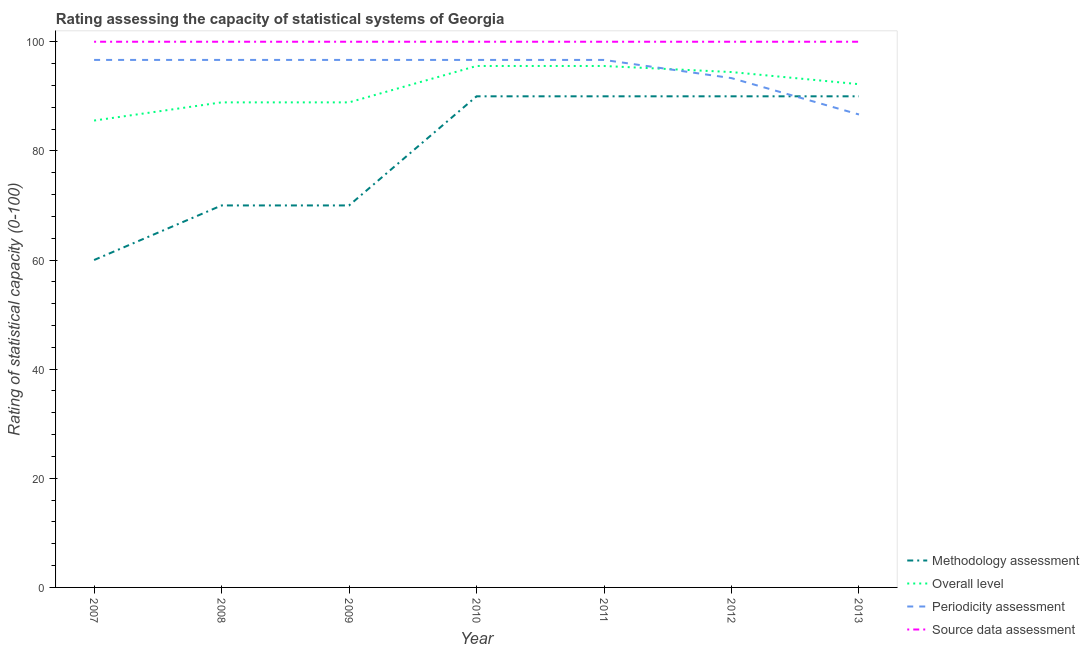How many different coloured lines are there?
Provide a succinct answer. 4. What is the overall level rating in 2008?
Ensure brevity in your answer.  88.89. Across all years, what is the maximum overall level rating?
Your answer should be compact. 95.56. Across all years, what is the minimum periodicity assessment rating?
Your response must be concise. 86.67. What is the total periodicity assessment rating in the graph?
Your answer should be very brief. 663.33. What is the difference between the overall level rating in 2010 and that in 2011?
Keep it short and to the point. 0. What is the difference between the methodology assessment rating in 2007 and the periodicity assessment rating in 2008?
Your answer should be very brief. -36.67. What is the average source data assessment rating per year?
Make the answer very short. 100. In the year 2011, what is the difference between the methodology assessment rating and overall level rating?
Your answer should be very brief. -5.56. What is the ratio of the methodology assessment rating in 2007 to that in 2010?
Provide a succinct answer. 0.67. Is the difference between the source data assessment rating in 2009 and 2011 greater than the difference between the methodology assessment rating in 2009 and 2011?
Your answer should be compact. Yes. In how many years, is the source data assessment rating greater than the average source data assessment rating taken over all years?
Your response must be concise. 0. Is the sum of the overall level rating in 2008 and 2009 greater than the maximum source data assessment rating across all years?
Make the answer very short. Yes. Is it the case that in every year, the sum of the methodology assessment rating and overall level rating is greater than the periodicity assessment rating?
Provide a short and direct response. Yes. How many lines are there?
Your response must be concise. 4. How many years are there in the graph?
Provide a short and direct response. 7. What is the difference between two consecutive major ticks on the Y-axis?
Offer a terse response. 20. Are the values on the major ticks of Y-axis written in scientific E-notation?
Your answer should be very brief. No. What is the title of the graph?
Ensure brevity in your answer.  Rating assessing the capacity of statistical systems of Georgia. Does "Primary education" appear as one of the legend labels in the graph?
Your answer should be compact. No. What is the label or title of the Y-axis?
Provide a succinct answer. Rating of statistical capacity (0-100). What is the Rating of statistical capacity (0-100) of Methodology assessment in 2007?
Your answer should be very brief. 60. What is the Rating of statistical capacity (0-100) in Overall level in 2007?
Your response must be concise. 85.56. What is the Rating of statistical capacity (0-100) in Periodicity assessment in 2007?
Offer a very short reply. 96.67. What is the Rating of statistical capacity (0-100) of Overall level in 2008?
Keep it short and to the point. 88.89. What is the Rating of statistical capacity (0-100) in Periodicity assessment in 2008?
Your response must be concise. 96.67. What is the Rating of statistical capacity (0-100) of Source data assessment in 2008?
Offer a very short reply. 100. What is the Rating of statistical capacity (0-100) of Methodology assessment in 2009?
Your answer should be very brief. 70. What is the Rating of statistical capacity (0-100) of Overall level in 2009?
Ensure brevity in your answer.  88.89. What is the Rating of statistical capacity (0-100) in Periodicity assessment in 2009?
Ensure brevity in your answer.  96.67. What is the Rating of statistical capacity (0-100) in Overall level in 2010?
Your answer should be compact. 95.56. What is the Rating of statistical capacity (0-100) of Periodicity assessment in 2010?
Your response must be concise. 96.67. What is the Rating of statistical capacity (0-100) in Source data assessment in 2010?
Provide a short and direct response. 100. What is the Rating of statistical capacity (0-100) in Methodology assessment in 2011?
Your answer should be compact. 90. What is the Rating of statistical capacity (0-100) of Overall level in 2011?
Provide a short and direct response. 95.56. What is the Rating of statistical capacity (0-100) of Periodicity assessment in 2011?
Keep it short and to the point. 96.67. What is the Rating of statistical capacity (0-100) of Source data assessment in 2011?
Offer a very short reply. 100. What is the Rating of statistical capacity (0-100) of Methodology assessment in 2012?
Make the answer very short. 90. What is the Rating of statistical capacity (0-100) in Overall level in 2012?
Provide a succinct answer. 94.44. What is the Rating of statistical capacity (0-100) of Periodicity assessment in 2012?
Your answer should be compact. 93.33. What is the Rating of statistical capacity (0-100) of Source data assessment in 2012?
Ensure brevity in your answer.  100. What is the Rating of statistical capacity (0-100) of Methodology assessment in 2013?
Your answer should be very brief. 90. What is the Rating of statistical capacity (0-100) of Overall level in 2013?
Offer a very short reply. 92.22. What is the Rating of statistical capacity (0-100) in Periodicity assessment in 2013?
Your response must be concise. 86.67. Across all years, what is the maximum Rating of statistical capacity (0-100) of Methodology assessment?
Offer a terse response. 90. Across all years, what is the maximum Rating of statistical capacity (0-100) in Overall level?
Your response must be concise. 95.56. Across all years, what is the maximum Rating of statistical capacity (0-100) of Periodicity assessment?
Offer a very short reply. 96.67. Across all years, what is the maximum Rating of statistical capacity (0-100) in Source data assessment?
Make the answer very short. 100. Across all years, what is the minimum Rating of statistical capacity (0-100) in Overall level?
Your response must be concise. 85.56. Across all years, what is the minimum Rating of statistical capacity (0-100) of Periodicity assessment?
Offer a very short reply. 86.67. Across all years, what is the minimum Rating of statistical capacity (0-100) in Source data assessment?
Offer a very short reply. 100. What is the total Rating of statistical capacity (0-100) in Methodology assessment in the graph?
Your response must be concise. 560. What is the total Rating of statistical capacity (0-100) of Overall level in the graph?
Make the answer very short. 641.11. What is the total Rating of statistical capacity (0-100) of Periodicity assessment in the graph?
Your answer should be very brief. 663.33. What is the total Rating of statistical capacity (0-100) of Source data assessment in the graph?
Your response must be concise. 700. What is the difference between the Rating of statistical capacity (0-100) of Methodology assessment in 2007 and that in 2008?
Provide a short and direct response. -10. What is the difference between the Rating of statistical capacity (0-100) in Overall level in 2007 and that in 2008?
Ensure brevity in your answer.  -3.33. What is the difference between the Rating of statistical capacity (0-100) in Periodicity assessment in 2007 and that in 2008?
Provide a short and direct response. 0. What is the difference between the Rating of statistical capacity (0-100) in Periodicity assessment in 2007 and that in 2009?
Keep it short and to the point. 0. What is the difference between the Rating of statistical capacity (0-100) of Methodology assessment in 2007 and that in 2010?
Provide a short and direct response. -30. What is the difference between the Rating of statistical capacity (0-100) in Overall level in 2007 and that in 2010?
Your answer should be very brief. -10. What is the difference between the Rating of statistical capacity (0-100) of Periodicity assessment in 2007 and that in 2010?
Offer a very short reply. 0. What is the difference between the Rating of statistical capacity (0-100) of Methodology assessment in 2007 and that in 2011?
Offer a very short reply. -30. What is the difference between the Rating of statistical capacity (0-100) of Periodicity assessment in 2007 and that in 2011?
Offer a terse response. 0. What is the difference between the Rating of statistical capacity (0-100) in Overall level in 2007 and that in 2012?
Keep it short and to the point. -8.89. What is the difference between the Rating of statistical capacity (0-100) in Overall level in 2007 and that in 2013?
Make the answer very short. -6.67. What is the difference between the Rating of statistical capacity (0-100) in Overall level in 2008 and that in 2009?
Provide a succinct answer. 0. What is the difference between the Rating of statistical capacity (0-100) in Source data assessment in 2008 and that in 2009?
Give a very brief answer. 0. What is the difference between the Rating of statistical capacity (0-100) in Methodology assessment in 2008 and that in 2010?
Your response must be concise. -20. What is the difference between the Rating of statistical capacity (0-100) of Overall level in 2008 and that in 2010?
Make the answer very short. -6.67. What is the difference between the Rating of statistical capacity (0-100) in Methodology assessment in 2008 and that in 2011?
Ensure brevity in your answer.  -20. What is the difference between the Rating of statistical capacity (0-100) in Overall level in 2008 and that in 2011?
Provide a short and direct response. -6.67. What is the difference between the Rating of statistical capacity (0-100) of Periodicity assessment in 2008 and that in 2011?
Give a very brief answer. 0. What is the difference between the Rating of statistical capacity (0-100) of Source data assessment in 2008 and that in 2011?
Make the answer very short. 0. What is the difference between the Rating of statistical capacity (0-100) in Methodology assessment in 2008 and that in 2012?
Offer a very short reply. -20. What is the difference between the Rating of statistical capacity (0-100) in Overall level in 2008 and that in 2012?
Your response must be concise. -5.56. What is the difference between the Rating of statistical capacity (0-100) in Periodicity assessment in 2008 and that in 2012?
Make the answer very short. 3.33. What is the difference between the Rating of statistical capacity (0-100) in Methodology assessment in 2008 and that in 2013?
Your response must be concise. -20. What is the difference between the Rating of statistical capacity (0-100) of Overall level in 2008 and that in 2013?
Provide a short and direct response. -3.33. What is the difference between the Rating of statistical capacity (0-100) of Periodicity assessment in 2008 and that in 2013?
Provide a short and direct response. 10. What is the difference between the Rating of statistical capacity (0-100) in Source data assessment in 2008 and that in 2013?
Provide a short and direct response. 0. What is the difference between the Rating of statistical capacity (0-100) of Methodology assessment in 2009 and that in 2010?
Ensure brevity in your answer.  -20. What is the difference between the Rating of statistical capacity (0-100) of Overall level in 2009 and that in 2010?
Your response must be concise. -6.67. What is the difference between the Rating of statistical capacity (0-100) in Periodicity assessment in 2009 and that in 2010?
Your answer should be very brief. 0. What is the difference between the Rating of statistical capacity (0-100) in Source data assessment in 2009 and that in 2010?
Offer a very short reply. 0. What is the difference between the Rating of statistical capacity (0-100) of Methodology assessment in 2009 and that in 2011?
Your answer should be very brief. -20. What is the difference between the Rating of statistical capacity (0-100) in Overall level in 2009 and that in 2011?
Your answer should be compact. -6.67. What is the difference between the Rating of statistical capacity (0-100) in Overall level in 2009 and that in 2012?
Your answer should be very brief. -5.56. What is the difference between the Rating of statistical capacity (0-100) in Periodicity assessment in 2009 and that in 2012?
Your answer should be compact. 3.33. What is the difference between the Rating of statistical capacity (0-100) in Source data assessment in 2009 and that in 2012?
Make the answer very short. 0. What is the difference between the Rating of statistical capacity (0-100) of Overall level in 2009 and that in 2013?
Offer a terse response. -3.33. What is the difference between the Rating of statistical capacity (0-100) in Source data assessment in 2009 and that in 2013?
Keep it short and to the point. 0. What is the difference between the Rating of statistical capacity (0-100) in Methodology assessment in 2010 and that in 2011?
Give a very brief answer. 0. What is the difference between the Rating of statistical capacity (0-100) of Overall level in 2010 and that in 2011?
Ensure brevity in your answer.  0. What is the difference between the Rating of statistical capacity (0-100) in Periodicity assessment in 2010 and that in 2011?
Offer a very short reply. 0. What is the difference between the Rating of statistical capacity (0-100) of Source data assessment in 2010 and that in 2011?
Provide a short and direct response. 0. What is the difference between the Rating of statistical capacity (0-100) of Methodology assessment in 2010 and that in 2012?
Give a very brief answer. 0. What is the difference between the Rating of statistical capacity (0-100) in Methodology assessment in 2010 and that in 2013?
Your answer should be very brief. 0. What is the difference between the Rating of statistical capacity (0-100) in Overall level in 2010 and that in 2013?
Your answer should be compact. 3.33. What is the difference between the Rating of statistical capacity (0-100) in Methodology assessment in 2011 and that in 2012?
Make the answer very short. 0. What is the difference between the Rating of statistical capacity (0-100) of Periodicity assessment in 2011 and that in 2012?
Give a very brief answer. 3.33. What is the difference between the Rating of statistical capacity (0-100) of Source data assessment in 2011 and that in 2012?
Your response must be concise. 0. What is the difference between the Rating of statistical capacity (0-100) in Overall level in 2011 and that in 2013?
Give a very brief answer. 3.33. What is the difference between the Rating of statistical capacity (0-100) in Overall level in 2012 and that in 2013?
Offer a terse response. 2.22. What is the difference between the Rating of statistical capacity (0-100) of Periodicity assessment in 2012 and that in 2013?
Your answer should be very brief. 6.67. What is the difference between the Rating of statistical capacity (0-100) in Source data assessment in 2012 and that in 2013?
Provide a succinct answer. 0. What is the difference between the Rating of statistical capacity (0-100) in Methodology assessment in 2007 and the Rating of statistical capacity (0-100) in Overall level in 2008?
Your answer should be very brief. -28.89. What is the difference between the Rating of statistical capacity (0-100) in Methodology assessment in 2007 and the Rating of statistical capacity (0-100) in Periodicity assessment in 2008?
Your response must be concise. -36.67. What is the difference between the Rating of statistical capacity (0-100) of Methodology assessment in 2007 and the Rating of statistical capacity (0-100) of Source data assessment in 2008?
Keep it short and to the point. -40. What is the difference between the Rating of statistical capacity (0-100) in Overall level in 2007 and the Rating of statistical capacity (0-100) in Periodicity assessment in 2008?
Provide a succinct answer. -11.11. What is the difference between the Rating of statistical capacity (0-100) of Overall level in 2007 and the Rating of statistical capacity (0-100) of Source data assessment in 2008?
Make the answer very short. -14.44. What is the difference between the Rating of statistical capacity (0-100) of Methodology assessment in 2007 and the Rating of statistical capacity (0-100) of Overall level in 2009?
Give a very brief answer. -28.89. What is the difference between the Rating of statistical capacity (0-100) in Methodology assessment in 2007 and the Rating of statistical capacity (0-100) in Periodicity assessment in 2009?
Ensure brevity in your answer.  -36.67. What is the difference between the Rating of statistical capacity (0-100) of Methodology assessment in 2007 and the Rating of statistical capacity (0-100) of Source data assessment in 2009?
Give a very brief answer. -40. What is the difference between the Rating of statistical capacity (0-100) in Overall level in 2007 and the Rating of statistical capacity (0-100) in Periodicity assessment in 2009?
Keep it short and to the point. -11.11. What is the difference between the Rating of statistical capacity (0-100) in Overall level in 2007 and the Rating of statistical capacity (0-100) in Source data assessment in 2009?
Offer a terse response. -14.44. What is the difference between the Rating of statistical capacity (0-100) of Periodicity assessment in 2007 and the Rating of statistical capacity (0-100) of Source data assessment in 2009?
Offer a terse response. -3.33. What is the difference between the Rating of statistical capacity (0-100) in Methodology assessment in 2007 and the Rating of statistical capacity (0-100) in Overall level in 2010?
Offer a very short reply. -35.56. What is the difference between the Rating of statistical capacity (0-100) of Methodology assessment in 2007 and the Rating of statistical capacity (0-100) of Periodicity assessment in 2010?
Ensure brevity in your answer.  -36.67. What is the difference between the Rating of statistical capacity (0-100) in Overall level in 2007 and the Rating of statistical capacity (0-100) in Periodicity assessment in 2010?
Provide a succinct answer. -11.11. What is the difference between the Rating of statistical capacity (0-100) in Overall level in 2007 and the Rating of statistical capacity (0-100) in Source data assessment in 2010?
Provide a short and direct response. -14.44. What is the difference between the Rating of statistical capacity (0-100) in Methodology assessment in 2007 and the Rating of statistical capacity (0-100) in Overall level in 2011?
Provide a succinct answer. -35.56. What is the difference between the Rating of statistical capacity (0-100) in Methodology assessment in 2007 and the Rating of statistical capacity (0-100) in Periodicity assessment in 2011?
Keep it short and to the point. -36.67. What is the difference between the Rating of statistical capacity (0-100) of Overall level in 2007 and the Rating of statistical capacity (0-100) of Periodicity assessment in 2011?
Offer a terse response. -11.11. What is the difference between the Rating of statistical capacity (0-100) of Overall level in 2007 and the Rating of statistical capacity (0-100) of Source data assessment in 2011?
Offer a very short reply. -14.44. What is the difference between the Rating of statistical capacity (0-100) of Periodicity assessment in 2007 and the Rating of statistical capacity (0-100) of Source data assessment in 2011?
Provide a succinct answer. -3.33. What is the difference between the Rating of statistical capacity (0-100) in Methodology assessment in 2007 and the Rating of statistical capacity (0-100) in Overall level in 2012?
Offer a very short reply. -34.44. What is the difference between the Rating of statistical capacity (0-100) in Methodology assessment in 2007 and the Rating of statistical capacity (0-100) in Periodicity assessment in 2012?
Keep it short and to the point. -33.33. What is the difference between the Rating of statistical capacity (0-100) in Methodology assessment in 2007 and the Rating of statistical capacity (0-100) in Source data assessment in 2012?
Provide a succinct answer. -40. What is the difference between the Rating of statistical capacity (0-100) in Overall level in 2007 and the Rating of statistical capacity (0-100) in Periodicity assessment in 2012?
Give a very brief answer. -7.78. What is the difference between the Rating of statistical capacity (0-100) in Overall level in 2007 and the Rating of statistical capacity (0-100) in Source data assessment in 2012?
Your answer should be compact. -14.44. What is the difference between the Rating of statistical capacity (0-100) of Periodicity assessment in 2007 and the Rating of statistical capacity (0-100) of Source data assessment in 2012?
Give a very brief answer. -3.33. What is the difference between the Rating of statistical capacity (0-100) in Methodology assessment in 2007 and the Rating of statistical capacity (0-100) in Overall level in 2013?
Make the answer very short. -32.22. What is the difference between the Rating of statistical capacity (0-100) in Methodology assessment in 2007 and the Rating of statistical capacity (0-100) in Periodicity assessment in 2013?
Offer a terse response. -26.67. What is the difference between the Rating of statistical capacity (0-100) in Methodology assessment in 2007 and the Rating of statistical capacity (0-100) in Source data assessment in 2013?
Your response must be concise. -40. What is the difference between the Rating of statistical capacity (0-100) in Overall level in 2007 and the Rating of statistical capacity (0-100) in Periodicity assessment in 2013?
Ensure brevity in your answer.  -1.11. What is the difference between the Rating of statistical capacity (0-100) of Overall level in 2007 and the Rating of statistical capacity (0-100) of Source data assessment in 2013?
Ensure brevity in your answer.  -14.44. What is the difference between the Rating of statistical capacity (0-100) of Methodology assessment in 2008 and the Rating of statistical capacity (0-100) of Overall level in 2009?
Provide a short and direct response. -18.89. What is the difference between the Rating of statistical capacity (0-100) of Methodology assessment in 2008 and the Rating of statistical capacity (0-100) of Periodicity assessment in 2009?
Provide a short and direct response. -26.67. What is the difference between the Rating of statistical capacity (0-100) in Methodology assessment in 2008 and the Rating of statistical capacity (0-100) in Source data assessment in 2009?
Offer a terse response. -30. What is the difference between the Rating of statistical capacity (0-100) of Overall level in 2008 and the Rating of statistical capacity (0-100) of Periodicity assessment in 2009?
Provide a short and direct response. -7.78. What is the difference between the Rating of statistical capacity (0-100) in Overall level in 2008 and the Rating of statistical capacity (0-100) in Source data assessment in 2009?
Offer a terse response. -11.11. What is the difference between the Rating of statistical capacity (0-100) of Periodicity assessment in 2008 and the Rating of statistical capacity (0-100) of Source data assessment in 2009?
Offer a very short reply. -3.33. What is the difference between the Rating of statistical capacity (0-100) in Methodology assessment in 2008 and the Rating of statistical capacity (0-100) in Overall level in 2010?
Your answer should be very brief. -25.56. What is the difference between the Rating of statistical capacity (0-100) of Methodology assessment in 2008 and the Rating of statistical capacity (0-100) of Periodicity assessment in 2010?
Your answer should be compact. -26.67. What is the difference between the Rating of statistical capacity (0-100) of Methodology assessment in 2008 and the Rating of statistical capacity (0-100) of Source data assessment in 2010?
Your answer should be compact. -30. What is the difference between the Rating of statistical capacity (0-100) in Overall level in 2008 and the Rating of statistical capacity (0-100) in Periodicity assessment in 2010?
Your answer should be very brief. -7.78. What is the difference between the Rating of statistical capacity (0-100) in Overall level in 2008 and the Rating of statistical capacity (0-100) in Source data assessment in 2010?
Provide a succinct answer. -11.11. What is the difference between the Rating of statistical capacity (0-100) of Periodicity assessment in 2008 and the Rating of statistical capacity (0-100) of Source data assessment in 2010?
Make the answer very short. -3.33. What is the difference between the Rating of statistical capacity (0-100) in Methodology assessment in 2008 and the Rating of statistical capacity (0-100) in Overall level in 2011?
Offer a very short reply. -25.56. What is the difference between the Rating of statistical capacity (0-100) in Methodology assessment in 2008 and the Rating of statistical capacity (0-100) in Periodicity assessment in 2011?
Your answer should be compact. -26.67. What is the difference between the Rating of statistical capacity (0-100) of Methodology assessment in 2008 and the Rating of statistical capacity (0-100) of Source data assessment in 2011?
Give a very brief answer. -30. What is the difference between the Rating of statistical capacity (0-100) in Overall level in 2008 and the Rating of statistical capacity (0-100) in Periodicity assessment in 2011?
Your answer should be very brief. -7.78. What is the difference between the Rating of statistical capacity (0-100) of Overall level in 2008 and the Rating of statistical capacity (0-100) of Source data assessment in 2011?
Your answer should be very brief. -11.11. What is the difference between the Rating of statistical capacity (0-100) in Methodology assessment in 2008 and the Rating of statistical capacity (0-100) in Overall level in 2012?
Give a very brief answer. -24.44. What is the difference between the Rating of statistical capacity (0-100) of Methodology assessment in 2008 and the Rating of statistical capacity (0-100) of Periodicity assessment in 2012?
Keep it short and to the point. -23.33. What is the difference between the Rating of statistical capacity (0-100) in Methodology assessment in 2008 and the Rating of statistical capacity (0-100) in Source data assessment in 2012?
Your response must be concise. -30. What is the difference between the Rating of statistical capacity (0-100) of Overall level in 2008 and the Rating of statistical capacity (0-100) of Periodicity assessment in 2012?
Provide a succinct answer. -4.44. What is the difference between the Rating of statistical capacity (0-100) of Overall level in 2008 and the Rating of statistical capacity (0-100) of Source data assessment in 2012?
Offer a terse response. -11.11. What is the difference between the Rating of statistical capacity (0-100) in Periodicity assessment in 2008 and the Rating of statistical capacity (0-100) in Source data assessment in 2012?
Offer a terse response. -3.33. What is the difference between the Rating of statistical capacity (0-100) in Methodology assessment in 2008 and the Rating of statistical capacity (0-100) in Overall level in 2013?
Your response must be concise. -22.22. What is the difference between the Rating of statistical capacity (0-100) in Methodology assessment in 2008 and the Rating of statistical capacity (0-100) in Periodicity assessment in 2013?
Provide a short and direct response. -16.67. What is the difference between the Rating of statistical capacity (0-100) of Methodology assessment in 2008 and the Rating of statistical capacity (0-100) of Source data assessment in 2013?
Give a very brief answer. -30. What is the difference between the Rating of statistical capacity (0-100) of Overall level in 2008 and the Rating of statistical capacity (0-100) of Periodicity assessment in 2013?
Provide a succinct answer. 2.22. What is the difference between the Rating of statistical capacity (0-100) of Overall level in 2008 and the Rating of statistical capacity (0-100) of Source data assessment in 2013?
Offer a terse response. -11.11. What is the difference between the Rating of statistical capacity (0-100) in Periodicity assessment in 2008 and the Rating of statistical capacity (0-100) in Source data assessment in 2013?
Your answer should be compact. -3.33. What is the difference between the Rating of statistical capacity (0-100) of Methodology assessment in 2009 and the Rating of statistical capacity (0-100) of Overall level in 2010?
Give a very brief answer. -25.56. What is the difference between the Rating of statistical capacity (0-100) in Methodology assessment in 2009 and the Rating of statistical capacity (0-100) in Periodicity assessment in 2010?
Provide a succinct answer. -26.67. What is the difference between the Rating of statistical capacity (0-100) of Methodology assessment in 2009 and the Rating of statistical capacity (0-100) of Source data assessment in 2010?
Your answer should be very brief. -30. What is the difference between the Rating of statistical capacity (0-100) in Overall level in 2009 and the Rating of statistical capacity (0-100) in Periodicity assessment in 2010?
Provide a succinct answer. -7.78. What is the difference between the Rating of statistical capacity (0-100) of Overall level in 2009 and the Rating of statistical capacity (0-100) of Source data assessment in 2010?
Provide a short and direct response. -11.11. What is the difference between the Rating of statistical capacity (0-100) of Methodology assessment in 2009 and the Rating of statistical capacity (0-100) of Overall level in 2011?
Offer a very short reply. -25.56. What is the difference between the Rating of statistical capacity (0-100) in Methodology assessment in 2009 and the Rating of statistical capacity (0-100) in Periodicity assessment in 2011?
Ensure brevity in your answer.  -26.67. What is the difference between the Rating of statistical capacity (0-100) in Overall level in 2009 and the Rating of statistical capacity (0-100) in Periodicity assessment in 2011?
Make the answer very short. -7.78. What is the difference between the Rating of statistical capacity (0-100) of Overall level in 2009 and the Rating of statistical capacity (0-100) of Source data assessment in 2011?
Provide a short and direct response. -11.11. What is the difference between the Rating of statistical capacity (0-100) in Periodicity assessment in 2009 and the Rating of statistical capacity (0-100) in Source data assessment in 2011?
Offer a very short reply. -3.33. What is the difference between the Rating of statistical capacity (0-100) in Methodology assessment in 2009 and the Rating of statistical capacity (0-100) in Overall level in 2012?
Provide a short and direct response. -24.44. What is the difference between the Rating of statistical capacity (0-100) in Methodology assessment in 2009 and the Rating of statistical capacity (0-100) in Periodicity assessment in 2012?
Offer a terse response. -23.33. What is the difference between the Rating of statistical capacity (0-100) in Overall level in 2009 and the Rating of statistical capacity (0-100) in Periodicity assessment in 2012?
Make the answer very short. -4.44. What is the difference between the Rating of statistical capacity (0-100) of Overall level in 2009 and the Rating of statistical capacity (0-100) of Source data assessment in 2012?
Offer a very short reply. -11.11. What is the difference between the Rating of statistical capacity (0-100) of Methodology assessment in 2009 and the Rating of statistical capacity (0-100) of Overall level in 2013?
Provide a succinct answer. -22.22. What is the difference between the Rating of statistical capacity (0-100) in Methodology assessment in 2009 and the Rating of statistical capacity (0-100) in Periodicity assessment in 2013?
Provide a short and direct response. -16.67. What is the difference between the Rating of statistical capacity (0-100) of Methodology assessment in 2009 and the Rating of statistical capacity (0-100) of Source data assessment in 2013?
Your response must be concise. -30. What is the difference between the Rating of statistical capacity (0-100) in Overall level in 2009 and the Rating of statistical capacity (0-100) in Periodicity assessment in 2013?
Make the answer very short. 2.22. What is the difference between the Rating of statistical capacity (0-100) of Overall level in 2009 and the Rating of statistical capacity (0-100) of Source data assessment in 2013?
Give a very brief answer. -11.11. What is the difference between the Rating of statistical capacity (0-100) in Periodicity assessment in 2009 and the Rating of statistical capacity (0-100) in Source data assessment in 2013?
Offer a terse response. -3.33. What is the difference between the Rating of statistical capacity (0-100) of Methodology assessment in 2010 and the Rating of statistical capacity (0-100) of Overall level in 2011?
Offer a terse response. -5.56. What is the difference between the Rating of statistical capacity (0-100) in Methodology assessment in 2010 and the Rating of statistical capacity (0-100) in Periodicity assessment in 2011?
Ensure brevity in your answer.  -6.67. What is the difference between the Rating of statistical capacity (0-100) of Methodology assessment in 2010 and the Rating of statistical capacity (0-100) of Source data assessment in 2011?
Offer a very short reply. -10. What is the difference between the Rating of statistical capacity (0-100) of Overall level in 2010 and the Rating of statistical capacity (0-100) of Periodicity assessment in 2011?
Offer a terse response. -1.11. What is the difference between the Rating of statistical capacity (0-100) of Overall level in 2010 and the Rating of statistical capacity (0-100) of Source data assessment in 2011?
Ensure brevity in your answer.  -4.44. What is the difference between the Rating of statistical capacity (0-100) in Methodology assessment in 2010 and the Rating of statistical capacity (0-100) in Overall level in 2012?
Your response must be concise. -4.44. What is the difference between the Rating of statistical capacity (0-100) of Methodology assessment in 2010 and the Rating of statistical capacity (0-100) of Periodicity assessment in 2012?
Offer a terse response. -3.33. What is the difference between the Rating of statistical capacity (0-100) in Methodology assessment in 2010 and the Rating of statistical capacity (0-100) in Source data assessment in 2012?
Your answer should be very brief. -10. What is the difference between the Rating of statistical capacity (0-100) of Overall level in 2010 and the Rating of statistical capacity (0-100) of Periodicity assessment in 2012?
Ensure brevity in your answer.  2.22. What is the difference between the Rating of statistical capacity (0-100) of Overall level in 2010 and the Rating of statistical capacity (0-100) of Source data assessment in 2012?
Offer a very short reply. -4.44. What is the difference between the Rating of statistical capacity (0-100) in Methodology assessment in 2010 and the Rating of statistical capacity (0-100) in Overall level in 2013?
Offer a terse response. -2.22. What is the difference between the Rating of statistical capacity (0-100) in Methodology assessment in 2010 and the Rating of statistical capacity (0-100) in Source data assessment in 2013?
Your answer should be compact. -10. What is the difference between the Rating of statistical capacity (0-100) in Overall level in 2010 and the Rating of statistical capacity (0-100) in Periodicity assessment in 2013?
Keep it short and to the point. 8.89. What is the difference between the Rating of statistical capacity (0-100) of Overall level in 2010 and the Rating of statistical capacity (0-100) of Source data assessment in 2013?
Your answer should be very brief. -4.44. What is the difference between the Rating of statistical capacity (0-100) of Methodology assessment in 2011 and the Rating of statistical capacity (0-100) of Overall level in 2012?
Offer a terse response. -4.44. What is the difference between the Rating of statistical capacity (0-100) of Methodology assessment in 2011 and the Rating of statistical capacity (0-100) of Periodicity assessment in 2012?
Make the answer very short. -3.33. What is the difference between the Rating of statistical capacity (0-100) of Methodology assessment in 2011 and the Rating of statistical capacity (0-100) of Source data assessment in 2012?
Your response must be concise. -10. What is the difference between the Rating of statistical capacity (0-100) in Overall level in 2011 and the Rating of statistical capacity (0-100) in Periodicity assessment in 2012?
Your response must be concise. 2.22. What is the difference between the Rating of statistical capacity (0-100) in Overall level in 2011 and the Rating of statistical capacity (0-100) in Source data assessment in 2012?
Provide a succinct answer. -4.44. What is the difference between the Rating of statistical capacity (0-100) in Methodology assessment in 2011 and the Rating of statistical capacity (0-100) in Overall level in 2013?
Provide a succinct answer. -2.22. What is the difference between the Rating of statistical capacity (0-100) of Methodology assessment in 2011 and the Rating of statistical capacity (0-100) of Periodicity assessment in 2013?
Give a very brief answer. 3.33. What is the difference between the Rating of statistical capacity (0-100) of Overall level in 2011 and the Rating of statistical capacity (0-100) of Periodicity assessment in 2013?
Your response must be concise. 8.89. What is the difference between the Rating of statistical capacity (0-100) in Overall level in 2011 and the Rating of statistical capacity (0-100) in Source data assessment in 2013?
Offer a very short reply. -4.44. What is the difference between the Rating of statistical capacity (0-100) in Methodology assessment in 2012 and the Rating of statistical capacity (0-100) in Overall level in 2013?
Offer a terse response. -2.22. What is the difference between the Rating of statistical capacity (0-100) in Overall level in 2012 and the Rating of statistical capacity (0-100) in Periodicity assessment in 2013?
Provide a short and direct response. 7.78. What is the difference between the Rating of statistical capacity (0-100) of Overall level in 2012 and the Rating of statistical capacity (0-100) of Source data assessment in 2013?
Your answer should be very brief. -5.56. What is the difference between the Rating of statistical capacity (0-100) of Periodicity assessment in 2012 and the Rating of statistical capacity (0-100) of Source data assessment in 2013?
Give a very brief answer. -6.67. What is the average Rating of statistical capacity (0-100) in Methodology assessment per year?
Ensure brevity in your answer.  80. What is the average Rating of statistical capacity (0-100) in Overall level per year?
Provide a succinct answer. 91.59. What is the average Rating of statistical capacity (0-100) of Periodicity assessment per year?
Your answer should be very brief. 94.76. In the year 2007, what is the difference between the Rating of statistical capacity (0-100) of Methodology assessment and Rating of statistical capacity (0-100) of Overall level?
Your answer should be compact. -25.56. In the year 2007, what is the difference between the Rating of statistical capacity (0-100) of Methodology assessment and Rating of statistical capacity (0-100) of Periodicity assessment?
Offer a very short reply. -36.67. In the year 2007, what is the difference between the Rating of statistical capacity (0-100) in Overall level and Rating of statistical capacity (0-100) in Periodicity assessment?
Your response must be concise. -11.11. In the year 2007, what is the difference between the Rating of statistical capacity (0-100) in Overall level and Rating of statistical capacity (0-100) in Source data assessment?
Make the answer very short. -14.44. In the year 2008, what is the difference between the Rating of statistical capacity (0-100) of Methodology assessment and Rating of statistical capacity (0-100) of Overall level?
Offer a very short reply. -18.89. In the year 2008, what is the difference between the Rating of statistical capacity (0-100) of Methodology assessment and Rating of statistical capacity (0-100) of Periodicity assessment?
Provide a succinct answer. -26.67. In the year 2008, what is the difference between the Rating of statistical capacity (0-100) of Methodology assessment and Rating of statistical capacity (0-100) of Source data assessment?
Your answer should be compact. -30. In the year 2008, what is the difference between the Rating of statistical capacity (0-100) in Overall level and Rating of statistical capacity (0-100) in Periodicity assessment?
Offer a terse response. -7.78. In the year 2008, what is the difference between the Rating of statistical capacity (0-100) in Overall level and Rating of statistical capacity (0-100) in Source data assessment?
Offer a terse response. -11.11. In the year 2008, what is the difference between the Rating of statistical capacity (0-100) of Periodicity assessment and Rating of statistical capacity (0-100) of Source data assessment?
Give a very brief answer. -3.33. In the year 2009, what is the difference between the Rating of statistical capacity (0-100) in Methodology assessment and Rating of statistical capacity (0-100) in Overall level?
Ensure brevity in your answer.  -18.89. In the year 2009, what is the difference between the Rating of statistical capacity (0-100) of Methodology assessment and Rating of statistical capacity (0-100) of Periodicity assessment?
Your answer should be very brief. -26.67. In the year 2009, what is the difference between the Rating of statistical capacity (0-100) in Methodology assessment and Rating of statistical capacity (0-100) in Source data assessment?
Offer a very short reply. -30. In the year 2009, what is the difference between the Rating of statistical capacity (0-100) of Overall level and Rating of statistical capacity (0-100) of Periodicity assessment?
Provide a short and direct response. -7.78. In the year 2009, what is the difference between the Rating of statistical capacity (0-100) of Overall level and Rating of statistical capacity (0-100) of Source data assessment?
Provide a short and direct response. -11.11. In the year 2009, what is the difference between the Rating of statistical capacity (0-100) of Periodicity assessment and Rating of statistical capacity (0-100) of Source data assessment?
Make the answer very short. -3.33. In the year 2010, what is the difference between the Rating of statistical capacity (0-100) in Methodology assessment and Rating of statistical capacity (0-100) in Overall level?
Your response must be concise. -5.56. In the year 2010, what is the difference between the Rating of statistical capacity (0-100) of Methodology assessment and Rating of statistical capacity (0-100) of Periodicity assessment?
Give a very brief answer. -6.67. In the year 2010, what is the difference between the Rating of statistical capacity (0-100) of Overall level and Rating of statistical capacity (0-100) of Periodicity assessment?
Offer a very short reply. -1.11. In the year 2010, what is the difference between the Rating of statistical capacity (0-100) of Overall level and Rating of statistical capacity (0-100) of Source data assessment?
Keep it short and to the point. -4.44. In the year 2010, what is the difference between the Rating of statistical capacity (0-100) of Periodicity assessment and Rating of statistical capacity (0-100) of Source data assessment?
Give a very brief answer. -3.33. In the year 2011, what is the difference between the Rating of statistical capacity (0-100) in Methodology assessment and Rating of statistical capacity (0-100) in Overall level?
Your answer should be very brief. -5.56. In the year 2011, what is the difference between the Rating of statistical capacity (0-100) in Methodology assessment and Rating of statistical capacity (0-100) in Periodicity assessment?
Your answer should be very brief. -6.67. In the year 2011, what is the difference between the Rating of statistical capacity (0-100) in Overall level and Rating of statistical capacity (0-100) in Periodicity assessment?
Your answer should be compact. -1.11. In the year 2011, what is the difference between the Rating of statistical capacity (0-100) in Overall level and Rating of statistical capacity (0-100) in Source data assessment?
Offer a terse response. -4.44. In the year 2011, what is the difference between the Rating of statistical capacity (0-100) of Periodicity assessment and Rating of statistical capacity (0-100) of Source data assessment?
Give a very brief answer. -3.33. In the year 2012, what is the difference between the Rating of statistical capacity (0-100) in Methodology assessment and Rating of statistical capacity (0-100) in Overall level?
Give a very brief answer. -4.44. In the year 2012, what is the difference between the Rating of statistical capacity (0-100) in Methodology assessment and Rating of statistical capacity (0-100) in Periodicity assessment?
Your response must be concise. -3.33. In the year 2012, what is the difference between the Rating of statistical capacity (0-100) in Methodology assessment and Rating of statistical capacity (0-100) in Source data assessment?
Provide a short and direct response. -10. In the year 2012, what is the difference between the Rating of statistical capacity (0-100) of Overall level and Rating of statistical capacity (0-100) of Periodicity assessment?
Give a very brief answer. 1.11. In the year 2012, what is the difference between the Rating of statistical capacity (0-100) of Overall level and Rating of statistical capacity (0-100) of Source data assessment?
Your answer should be compact. -5.56. In the year 2012, what is the difference between the Rating of statistical capacity (0-100) of Periodicity assessment and Rating of statistical capacity (0-100) of Source data assessment?
Keep it short and to the point. -6.67. In the year 2013, what is the difference between the Rating of statistical capacity (0-100) of Methodology assessment and Rating of statistical capacity (0-100) of Overall level?
Your response must be concise. -2.22. In the year 2013, what is the difference between the Rating of statistical capacity (0-100) in Overall level and Rating of statistical capacity (0-100) in Periodicity assessment?
Ensure brevity in your answer.  5.56. In the year 2013, what is the difference between the Rating of statistical capacity (0-100) in Overall level and Rating of statistical capacity (0-100) in Source data assessment?
Make the answer very short. -7.78. In the year 2013, what is the difference between the Rating of statistical capacity (0-100) in Periodicity assessment and Rating of statistical capacity (0-100) in Source data assessment?
Provide a succinct answer. -13.33. What is the ratio of the Rating of statistical capacity (0-100) in Overall level in 2007 to that in 2008?
Provide a short and direct response. 0.96. What is the ratio of the Rating of statistical capacity (0-100) of Source data assessment in 2007 to that in 2008?
Provide a succinct answer. 1. What is the ratio of the Rating of statistical capacity (0-100) in Methodology assessment in 2007 to that in 2009?
Offer a terse response. 0.86. What is the ratio of the Rating of statistical capacity (0-100) of Overall level in 2007 to that in 2009?
Give a very brief answer. 0.96. What is the ratio of the Rating of statistical capacity (0-100) of Periodicity assessment in 2007 to that in 2009?
Make the answer very short. 1. What is the ratio of the Rating of statistical capacity (0-100) of Overall level in 2007 to that in 2010?
Your answer should be very brief. 0.9. What is the ratio of the Rating of statistical capacity (0-100) of Source data assessment in 2007 to that in 2010?
Give a very brief answer. 1. What is the ratio of the Rating of statistical capacity (0-100) of Methodology assessment in 2007 to that in 2011?
Offer a very short reply. 0.67. What is the ratio of the Rating of statistical capacity (0-100) of Overall level in 2007 to that in 2011?
Provide a short and direct response. 0.9. What is the ratio of the Rating of statistical capacity (0-100) of Overall level in 2007 to that in 2012?
Offer a very short reply. 0.91. What is the ratio of the Rating of statistical capacity (0-100) of Periodicity assessment in 2007 to that in 2012?
Provide a succinct answer. 1.04. What is the ratio of the Rating of statistical capacity (0-100) of Source data assessment in 2007 to that in 2012?
Keep it short and to the point. 1. What is the ratio of the Rating of statistical capacity (0-100) of Overall level in 2007 to that in 2013?
Your answer should be compact. 0.93. What is the ratio of the Rating of statistical capacity (0-100) of Periodicity assessment in 2007 to that in 2013?
Your answer should be very brief. 1.12. What is the ratio of the Rating of statistical capacity (0-100) of Source data assessment in 2008 to that in 2009?
Give a very brief answer. 1. What is the ratio of the Rating of statistical capacity (0-100) in Methodology assessment in 2008 to that in 2010?
Provide a short and direct response. 0.78. What is the ratio of the Rating of statistical capacity (0-100) of Overall level in 2008 to that in 2010?
Provide a short and direct response. 0.93. What is the ratio of the Rating of statistical capacity (0-100) in Periodicity assessment in 2008 to that in 2010?
Ensure brevity in your answer.  1. What is the ratio of the Rating of statistical capacity (0-100) of Overall level in 2008 to that in 2011?
Make the answer very short. 0.93. What is the ratio of the Rating of statistical capacity (0-100) of Periodicity assessment in 2008 to that in 2011?
Keep it short and to the point. 1. What is the ratio of the Rating of statistical capacity (0-100) in Source data assessment in 2008 to that in 2011?
Offer a terse response. 1. What is the ratio of the Rating of statistical capacity (0-100) of Methodology assessment in 2008 to that in 2012?
Provide a succinct answer. 0.78. What is the ratio of the Rating of statistical capacity (0-100) of Periodicity assessment in 2008 to that in 2012?
Offer a terse response. 1.04. What is the ratio of the Rating of statistical capacity (0-100) in Overall level in 2008 to that in 2013?
Offer a very short reply. 0.96. What is the ratio of the Rating of statistical capacity (0-100) in Periodicity assessment in 2008 to that in 2013?
Keep it short and to the point. 1.12. What is the ratio of the Rating of statistical capacity (0-100) in Source data assessment in 2008 to that in 2013?
Your response must be concise. 1. What is the ratio of the Rating of statistical capacity (0-100) in Methodology assessment in 2009 to that in 2010?
Offer a terse response. 0.78. What is the ratio of the Rating of statistical capacity (0-100) of Overall level in 2009 to that in 2010?
Offer a terse response. 0.93. What is the ratio of the Rating of statistical capacity (0-100) in Periodicity assessment in 2009 to that in 2010?
Ensure brevity in your answer.  1. What is the ratio of the Rating of statistical capacity (0-100) in Methodology assessment in 2009 to that in 2011?
Offer a terse response. 0.78. What is the ratio of the Rating of statistical capacity (0-100) of Overall level in 2009 to that in 2011?
Provide a succinct answer. 0.93. What is the ratio of the Rating of statistical capacity (0-100) of Periodicity assessment in 2009 to that in 2011?
Make the answer very short. 1. What is the ratio of the Rating of statistical capacity (0-100) of Methodology assessment in 2009 to that in 2012?
Your answer should be very brief. 0.78. What is the ratio of the Rating of statistical capacity (0-100) of Periodicity assessment in 2009 to that in 2012?
Your answer should be compact. 1.04. What is the ratio of the Rating of statistical capacity (0-100) in Methodology assessment in 2009 to that in 2013?
Make the answer very short. 0.78. What is the ratio of the Rating of statistical capacity (0-100) of Overall level in 2009 to that in 2013?
Your answer should be very brief. 0.96. What is the ratio of the Rating of statistical capacity (0-100) of Periodicity assessment in 2009 to that in 2013?
Provide a succinct answer. 1.12. What is the ratio of the Rating of statistical capacity (0-100) of Source data assessment in 2009 to that in 2013?
Your response must be concise. 1. What is the ratio of the Rating of statistical capacity (0-100) of Source data assessment in 2010 to that in 2011?
Ensure brevity in your answer.  1. What is the ratio of the Rating of statistical capacity (0-100) of Overall level in 2010 to that in 2012?
Make the answer very short. 1.01. What is the ratio of the Rating of statistical capacity (0-100) in Periodicity assessment in 2010 to that in 2012?
Your answer should be compact. 1.04. What is the ratio of the Rating of statistical capacity (0-100) in Source data assessment in 2010 to that in 2012?
Offer a terse response. 1. What is the ratio of the Rating of statistical capacity (0-100) of Overall level in 2010 to that in 2013?
Provide a succinct answer. 1.04. What is the ratio of the Rating of statistical capacity (0-100) in Periodicity assessment in 2010 to that in 2013?
Ensure brevity in your answer.  1.12. What is the ratio of the Rating of statistical capacity (0-100) in Source data assessment in 2010 to that in 2013?
Provide a short and direct response. 1. What is the ratio of the Rating of statistical capacity (0-100) of Overall level in 2011 to that in 2012?
Your answer should be compact. 1.01. What is the ratio of the Rating of statistical capacity (0-100) of Periodicity assessment in 2011 to that in 2012?
Keep it short and to the point. 1.04. What is the ratio of the Rating of statistical capacity (0-100) of Methodology assessment in 2011 to that in 2013?
Provide a short and direct response. 1. What is the ratio of the Rating of statistical capacity (0-100) in Overall level in 2011 to that in 2013?
Your answer should be compact. 1.04. What is the ratio of the Rating of statistical capacity (0-100) in Periodicity assessment in 2011 to that in 2013?
Keep it short and to the point. 1.12. What is the ratio of the Rating of statistical capacity (0-100) of Methodology assessment in 2012 to that in 2013?
Your response must be concise. 1. What is the ratio of the Rating of statistical capacity (0-100) in Overall level in 2012 to that in 2013?
Offer a terse response. 1.02. What is the ratio of the Rating of statistical capacity (0-100) in Periodicity assessment in 2012 to that in 2013?
Provide a short and direct response. 1.08. What is the ratio of the Rating of statistical capacity (0-100) in Source data assessment in 2012 to that in 2013?
Ensure brevity in your answer.  1. What is the difference between the highest and the second highest Rating of statistical capacity (0-100) in Periodicity assessment?
Offer a very short reply. 0. What is the difference between the highest and the lowest Rating of statistical capacity (0-100) of Methodology assessment?
Provide a succinct answer. 30. 